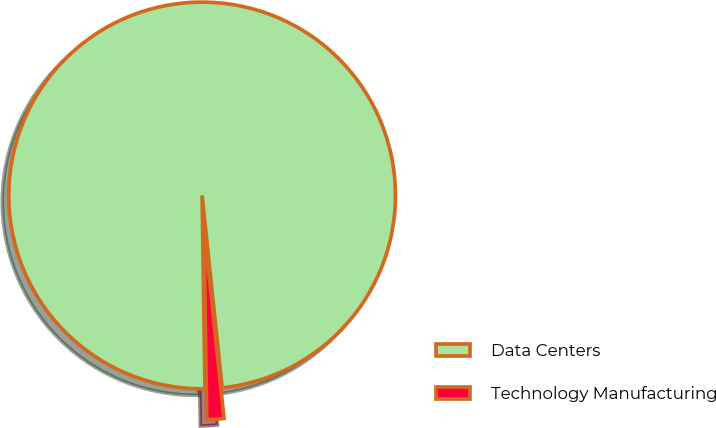Convert chart to OTSL. <chart><loc_0><loc_0><loc_500><loc_500><pie_chart><fcel>Data Centers<fcel>Technology Manufacturing<nl><fcel>98.58%<fcel>1.42%<nl></chart> 